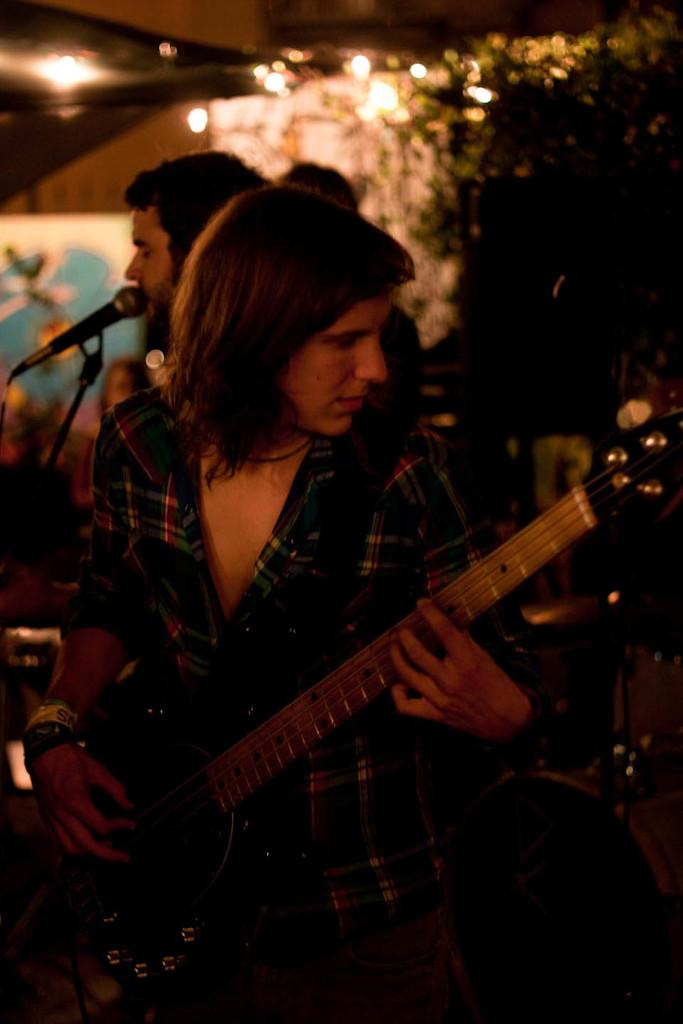How many people are in the image? There are three persons in the image. What is the woman doing in the image? The woman is playing a guitar. What is the man doing in the image? The man is singing on a microphone. What can be seen in the background of the image? There are lights and a tree visible in the background. How does the image show an increase in beef consumption? The image does not show an increase in beef consumption; it features a woman playing a guitar and a man singing on a microphone. What type of learning is taking place in the image? There is no indication of learning taking place in the image; it shows a musical performance. 